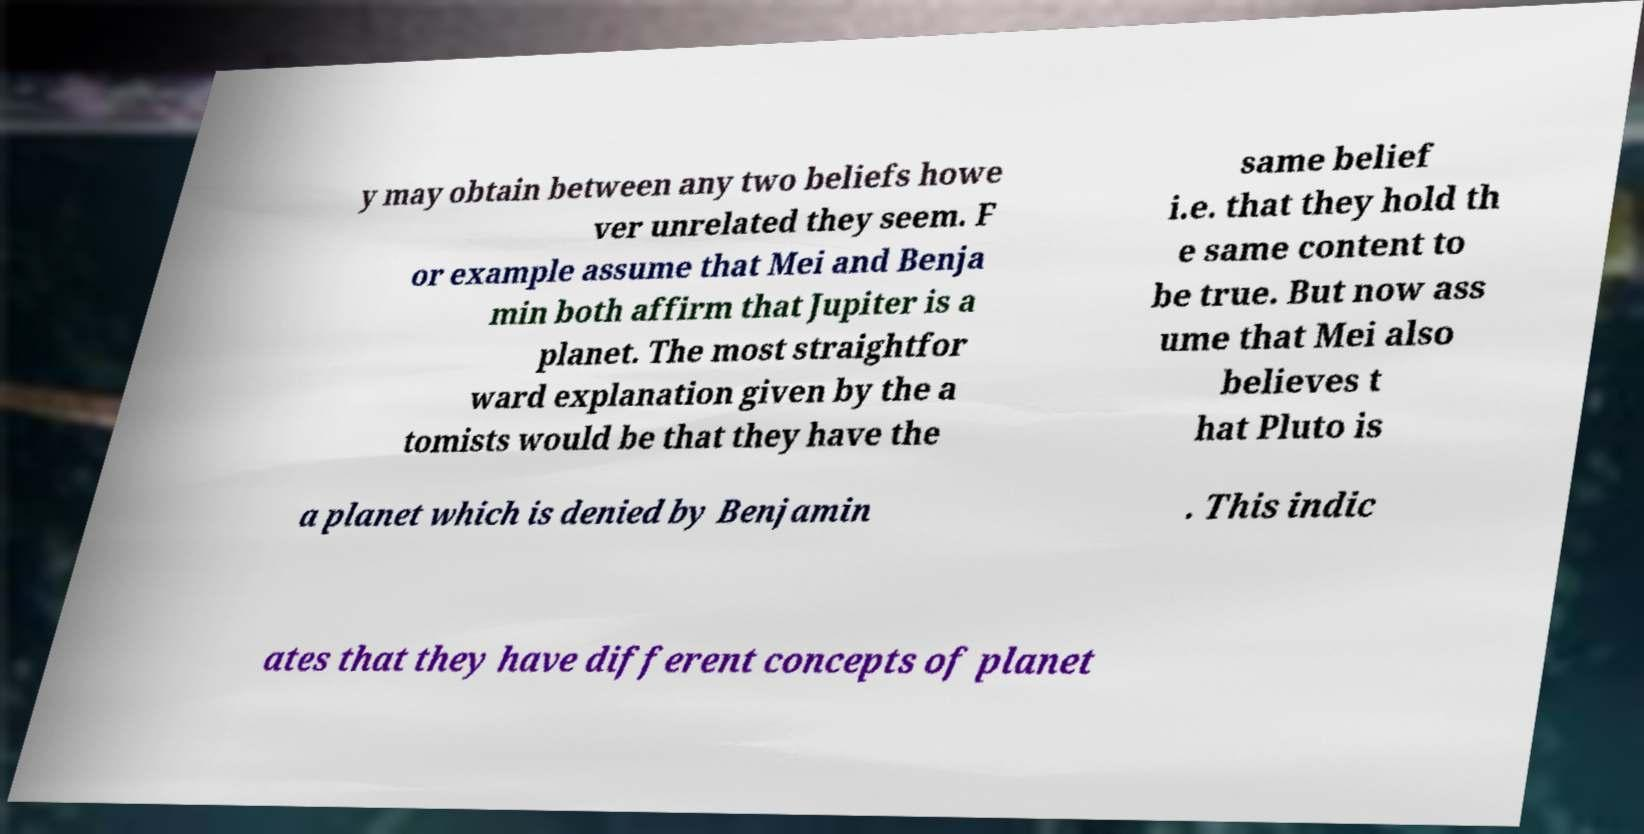For documentation purposes, I need the text within this image transcribed. Could you provide that? y may obtain between any two beliefs howe ver unrelated they seem. F or example assume that Mei and Benja min both affirm that Jupiter is a planet. The most straightfor ward explanation given by the a tomists would be that they have the same belief i.e. that they hold th e same content to be true. But now ass ume that Mei also believes t hat Pluto is a planet which is denied by Benjamin . This indic ates that they have different concepts of planet 